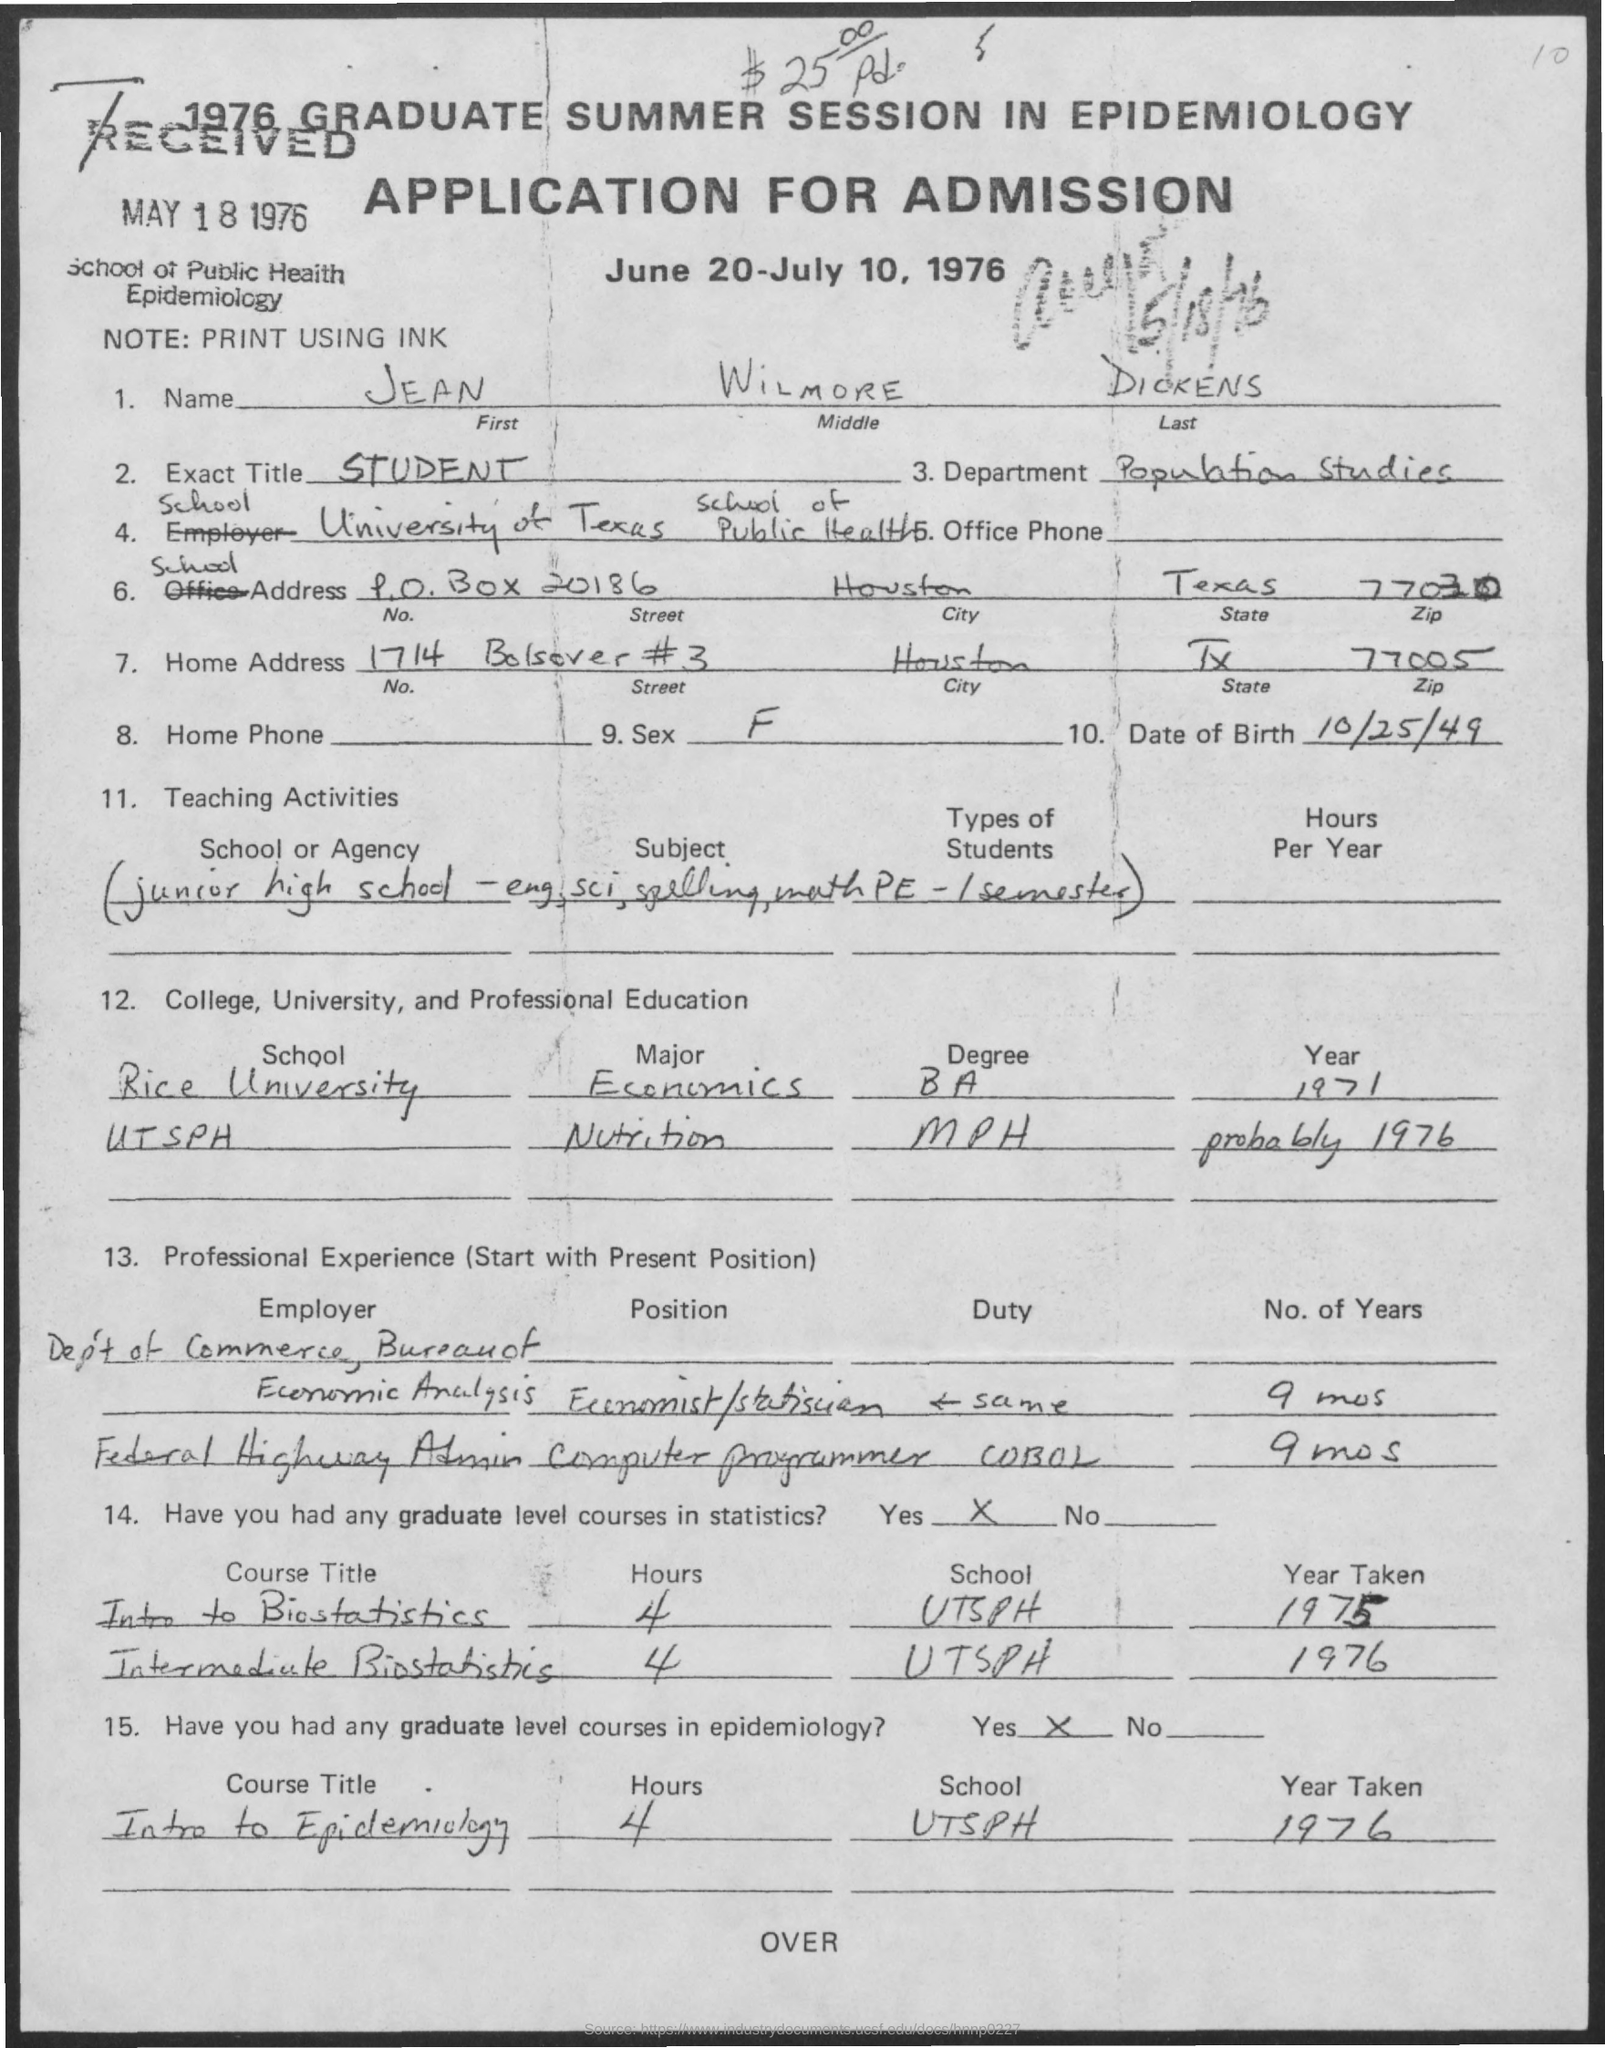What educational background does the applicant have as per this application? According to the application, the applicant completed a Bachelor of Arts (BA) in Economics at Rice University and a Master of Public Health (MPH) in Nutrition, likely in the year 1976, at the University of Texas School of Public Health (UTSPH). 